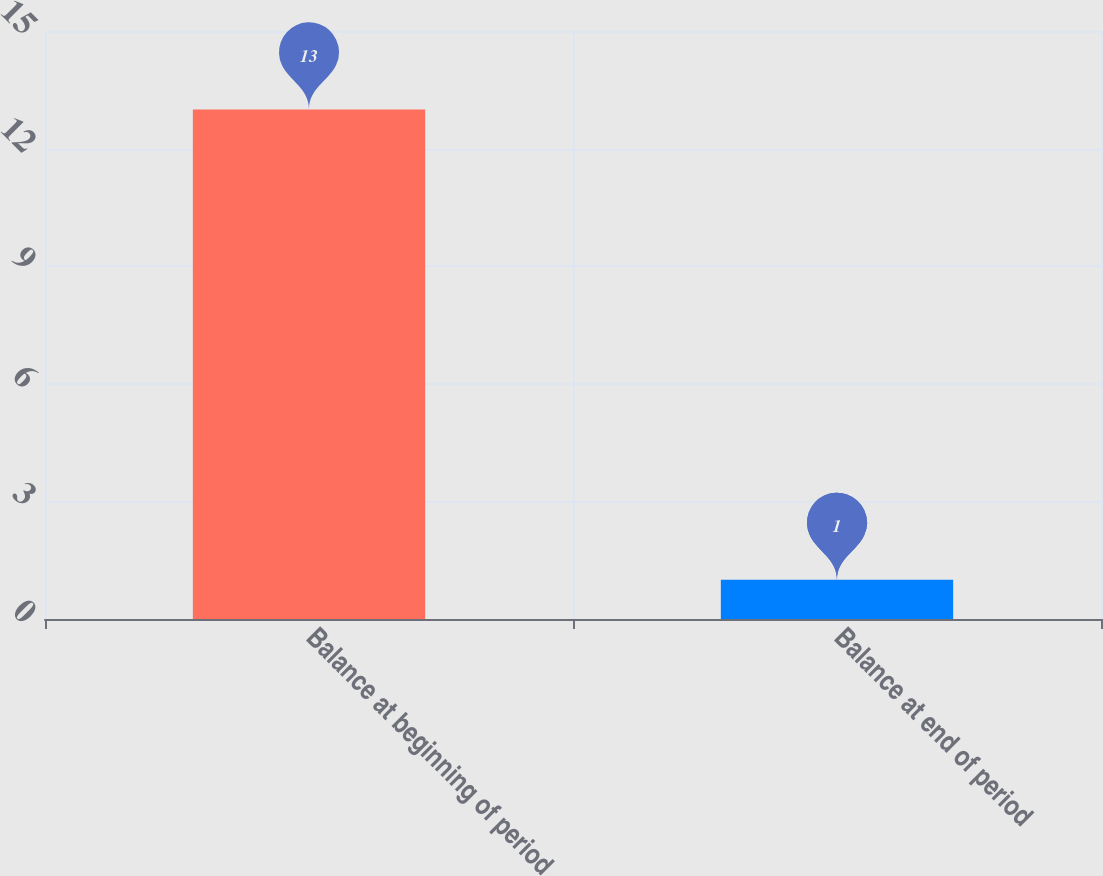<chart> <loc_0><loc_0><loc_500><loc_500><bar_chart><fcel>Balance at beginning of period<fcel>Balance at end of period<nl><fcel>13<fcel>1<nl></chart> 